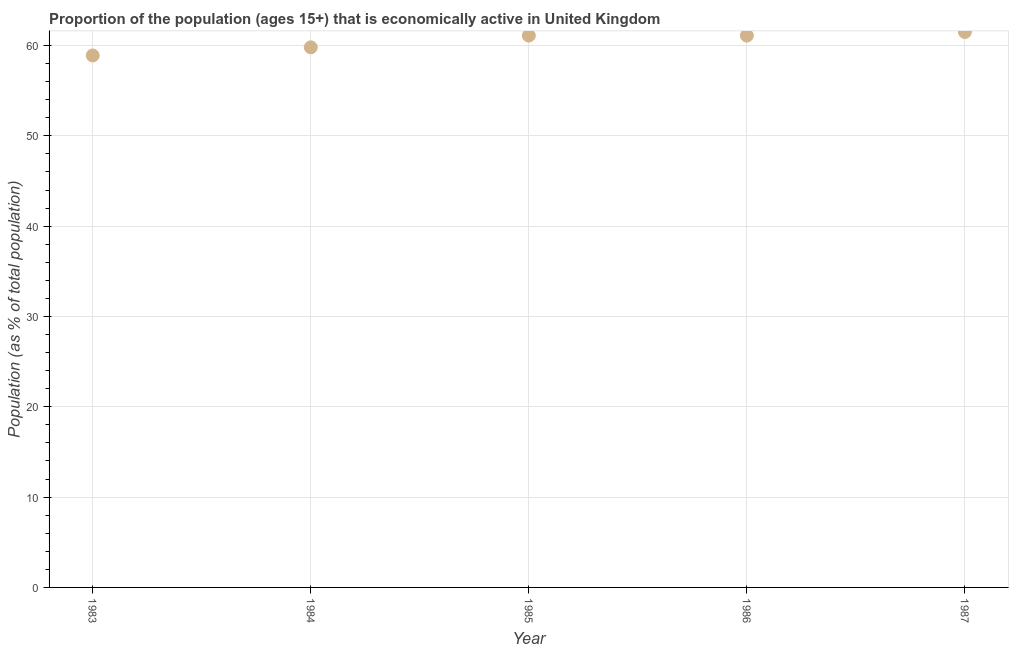What is the percentage of economically active population in 1987?
Provide a succinct answer. 61.5. Across all years, what is the maximum percentage of economically active population?
Make the answer very short. 61.5. Across all years, what is the minimum percentage of economically active population?
Your answer should be very brief. 58.9. In which year was the percentage of economically active population maximum?
Make the answer very short. 1987. In which year was the percentage of economically active population minimum?
Provide a short and direct response. 1983. What is the sum of the percentage of economically active population?
Ensure brevity in your answer.  302.4. What is the average percentage of economically active population per year?
Your answer should be compact. 60.48. What is the median percentage of economically active population?
Your response must be concise. 61.1. Do a majority of the years between 1983 and 1985 (inclusive) have percentage of economically active population greater than 56 %?
Make the answer very short. Yes. What is the ratio of the percentage of economically active population in 1985 to that in 1986?
Keep it short and to the point. 1. Is the difference between the percentage of economically active population in 1984 and 1987 greater than the difference between any two years?
Ensure brevity in your answer.  No. What is the difference between the highest and the second highest percentage of economically active population?
Ensure brevity in your answer.  0.4. What is the difference between the highest and the lowest percentage of economically active population?
Your response must be concise. 2.6. Does the percentage of economically active population monotonically increase over the years?
Your response must be concise. No. How many years are there in the graph?
Your response must be concise. 5. Are the values on the major ticks of Y-axis written in scientific E-notation?
Your answer should be very brief. No. Does the graph contain any zero values?
Your answer should be compact. No. Does the graph contain grids?
Ensure brevity in your answer.  Yes. What is the title of the graph?
Your answer should be very brief. Proportion of the population (ages 15+) that is economically active in United Kingdom. What is the label or title of the X-axis?
Ensure brevity in your answer.  Year. What is the label or title of the Y-axis?
Provide a short and direct response. Population (as % of total population). What is the Population (as % of total population) in 1983?
Give a very brief answer. 58.9. What is the Population (as % of total population) in 1984?
Provide a succinct answer. 59.8. What is the Population (as % of total population) in 1985?
Your response must be concise. 61.1. What is the Population (as % of total population) in 1986?
Ensure brevity in your answer.  61.1. What is the Population (as % of total population) in 1987?
Offer a very short reply. 61.5. What is the difference between the Population (as % of total population) in 1983 and 1984?
Provide a short and direct response. -0.9. What is the difference between the Population (as % of total population) in 1983 and 1985?
Provide a short and direct response. -2.2. What is the difference between the Population (as % of total population) in 1983 and 1986?
Make the answer very short. -2.2. What is the difference between the Population (as % of total population) in 1984 and 1987?
Make the answer very short. -1.7. What is the difference between the Population (as % of total population) in 1985 and 1987?
Make the answer very short. -0.4. What is the difference between the Population (as % of total population) in 1986 and 1987?
Your response must be concise. -0.4. What is the ratio of the Population (as % of total population) in 1983 to that in 1987?
Offer a terse response. 0.96. What is the ratio of the Population (as % of total population) in 1984 to that in 1987?
Offer a very short reply. 0.97. What is the ratio of the Population (as % of total population) in 1985 to that in 1986?
Provide a succinct answer. 1. What is the ratio of the Population (as % of total population) in 1986 to that in 1987?
Ensure brevity in your answer.  0.99. 